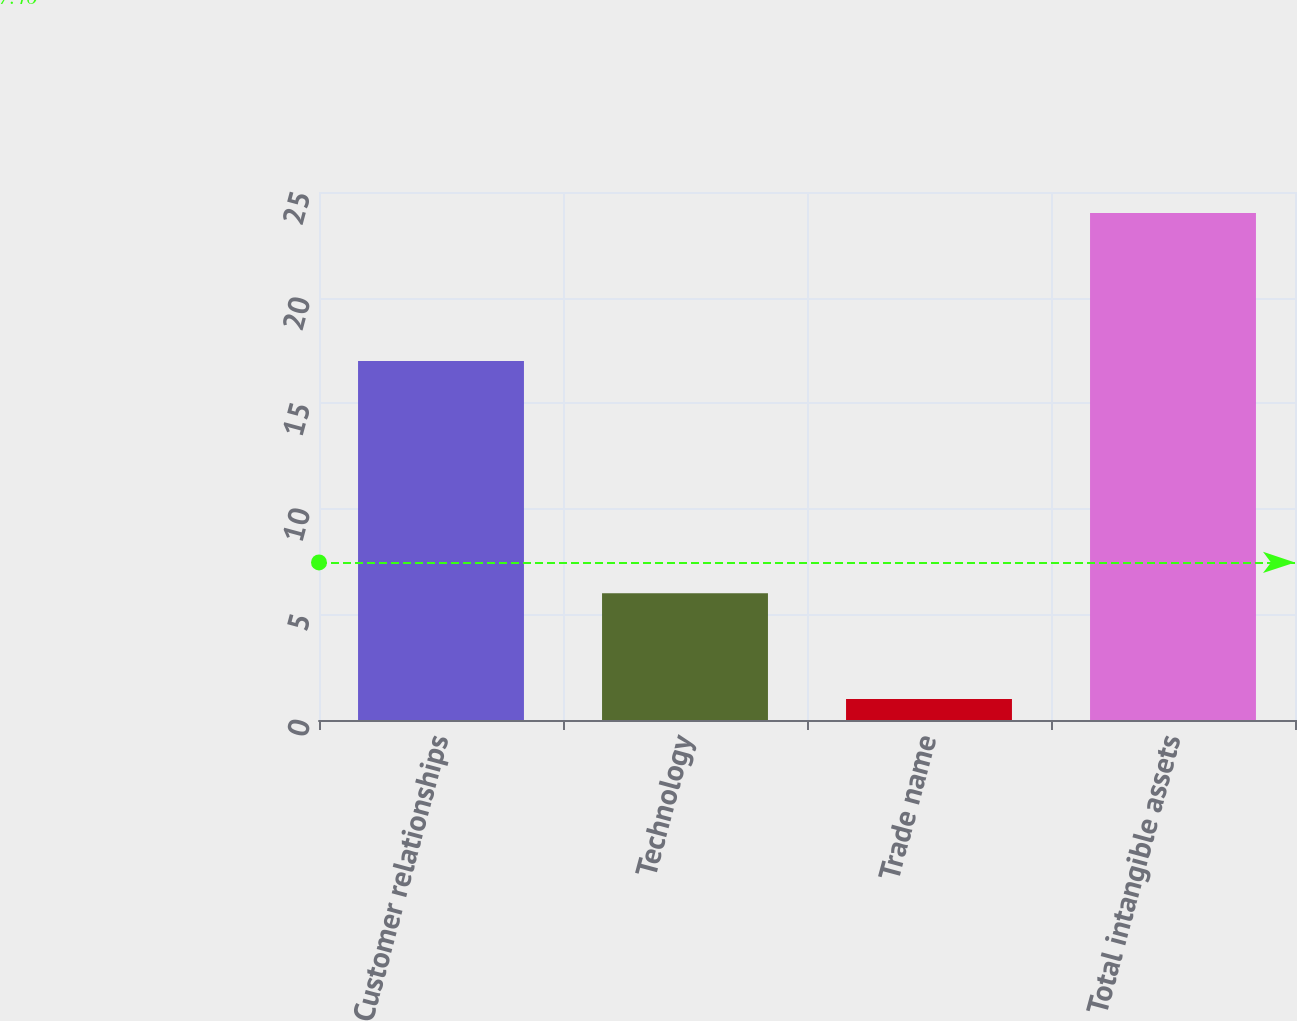Convert chart. <chart><loc_0><loc_0><loc_500><loc_500><bar_chart><fcel>Customer relationships<fcel>Technology<fcel>Trade name<fcel>Total intangible assets<nl><fcel>17<fcel>6<fcel>1<fcel>24<nl></chart> 